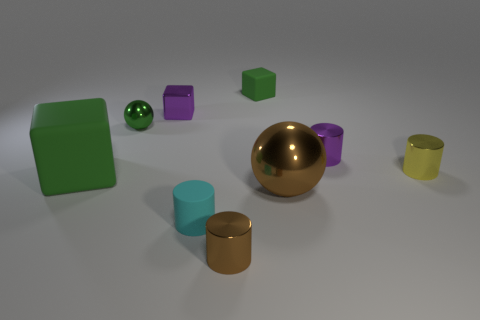Subtract 1 cylinders. How many cylinders are left? 3 Subtract all cylinders. How many objects are left? 5 Add 8 small balls. How many small balls exist? 9 Subtract 1 purple cylinders. How many objects are left? 8 Subtract all big brown rubber cubes. Subtract all cyan rubber cylinders. How many objects are left? 8 Add 6 purple shiny blocks. How many purple shiny blocks are left? 7 